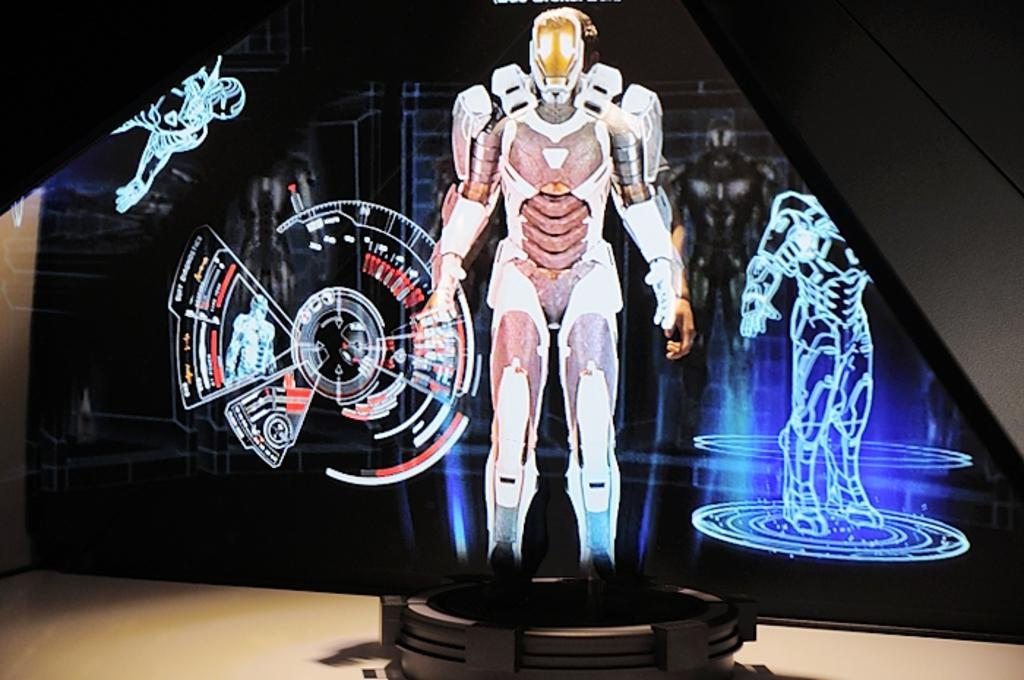What is on the floor in the image? There is an object on the floor in the image. What else can be seen in the image besides the object on the floor? There is a screen visible in the image. What is displayed on the screen? The screen displays structures of robots and other things. What type of spade is being used to dig in the image? There is no spade present in the image. What unit of measurement is being used to determine the distance between the robots in the image? The image does not provide information about the unit of measurement being used. 